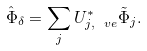Convert formula to latex. <formula><loc_0><loc_0><loc_500><loc_500>\hat { \Phi } _ { \delta } = \sum _ { j } U _ { j , \ v e } ^ { * } \tilde { \Phi } _ { j } .</formula> 